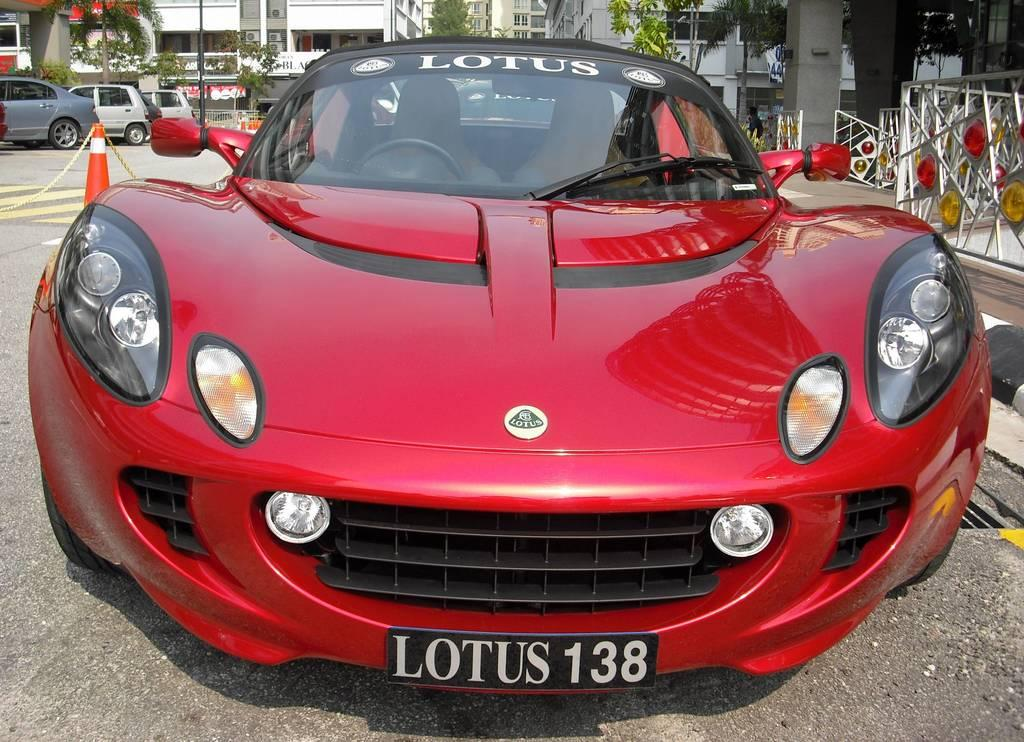What is happening on the road in the image? There are cars on a road in the image. What can be seen on the right side of the image? There are iron rods on the right side of the image. What is visible in the background of the image? There are trees and buildings in the background of the image. Where is the rake being used in the image? There is no rake present in the image. What is the mass of the cars on the road in the image? The mass of the cars cannot be determined from the image alone. 